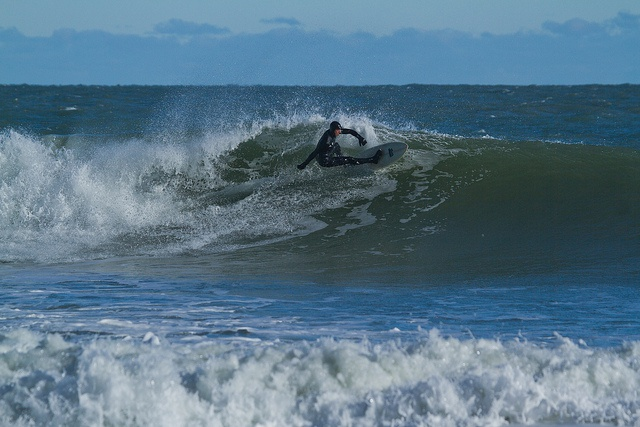Describe the objects in this image and their specific colors. I can see people in darkgray, black, gray, purple, and darkblue tones and surfboard in darkgray, purple, darkblue, black, and gray tones in this image. 